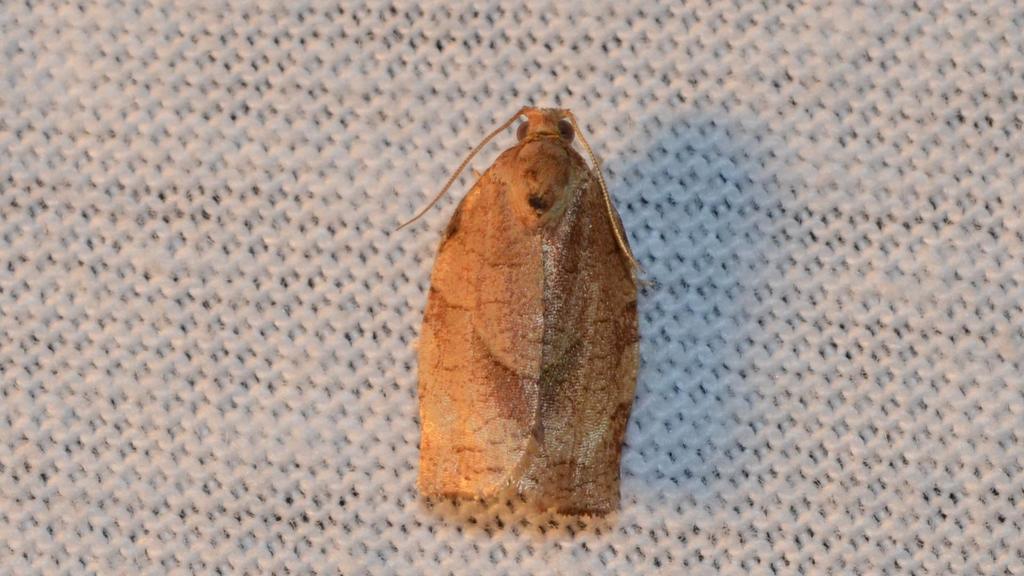Please provide a concise description of this image. This is a picture of a house moth on the path. 